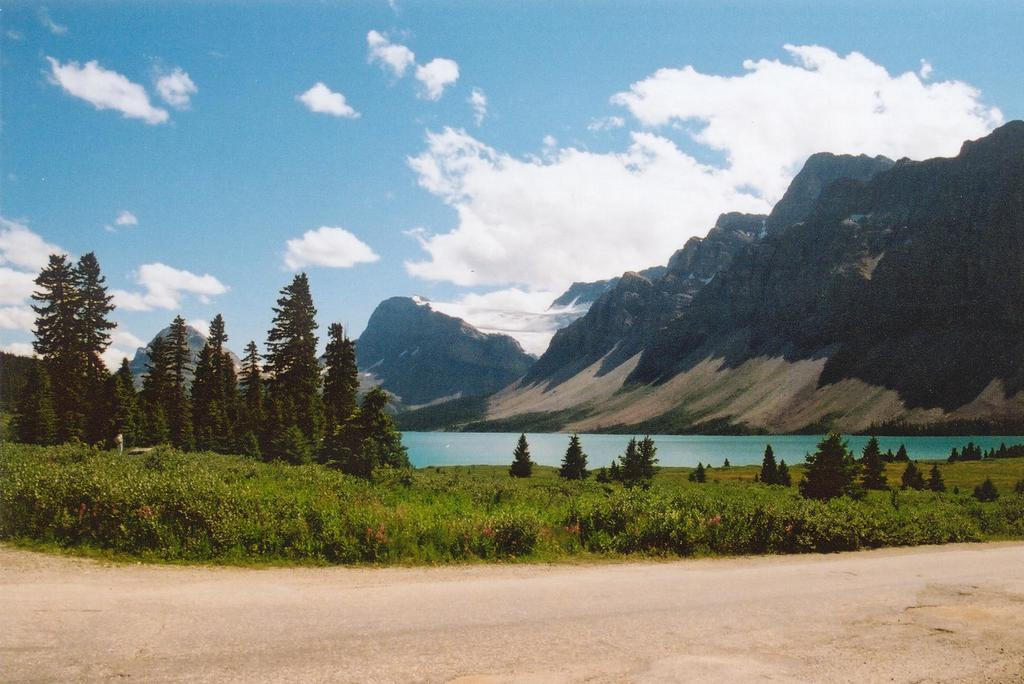What type of ground is visible in the image? The ground with grass is visible in the image. What type of vegetation can be seen in the image? Plants and trees are visible in the image. What type of natural landform is present in the image? Mountains are present in the image. What type of water feature is visible in the image? Water is visible in the image. What part of the natural environment is visible in the image? The sky is visible in the image. What type of weather can be inferred from the image? Clouds are present in the sky, suggesting that it might be a partly cloudy day. How many clocks are visible in the image? There are no clocks present in the image. What type of paint is used to create the mountains in the image? The image is a photograph, not a painting, so there is no paint used to create the mountains. 